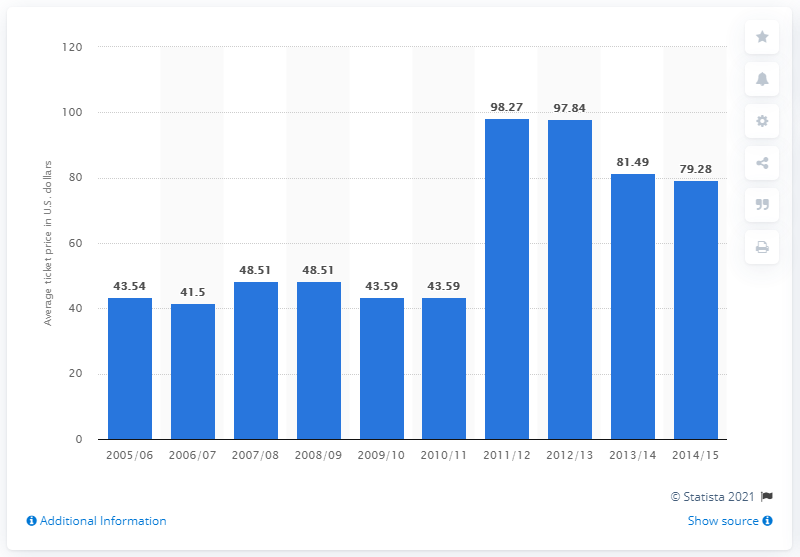Outline some significant characteristics in this image. In the 2005/2006 season, the average ticket price was 43.54. 